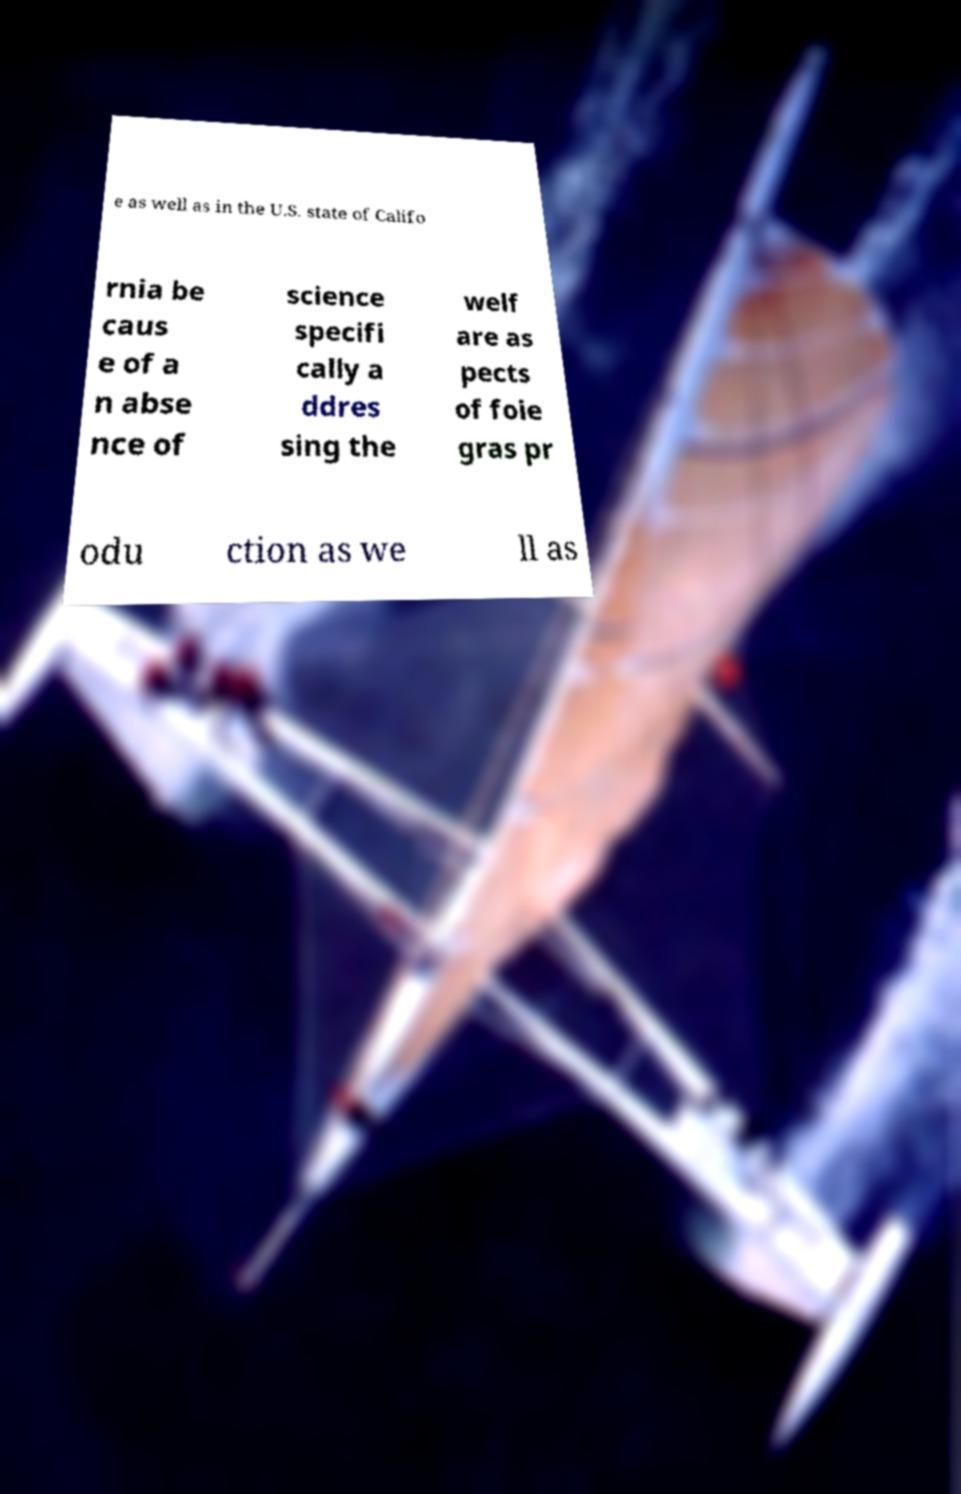Can you accurately transcribe the text from the provided image for me? e as well as in the U.S. state of Califo rnia be caus e of a n abse nce of science specifi cally a ddres sing the welf are as pects of foie gras pr odu ction as we ll as 